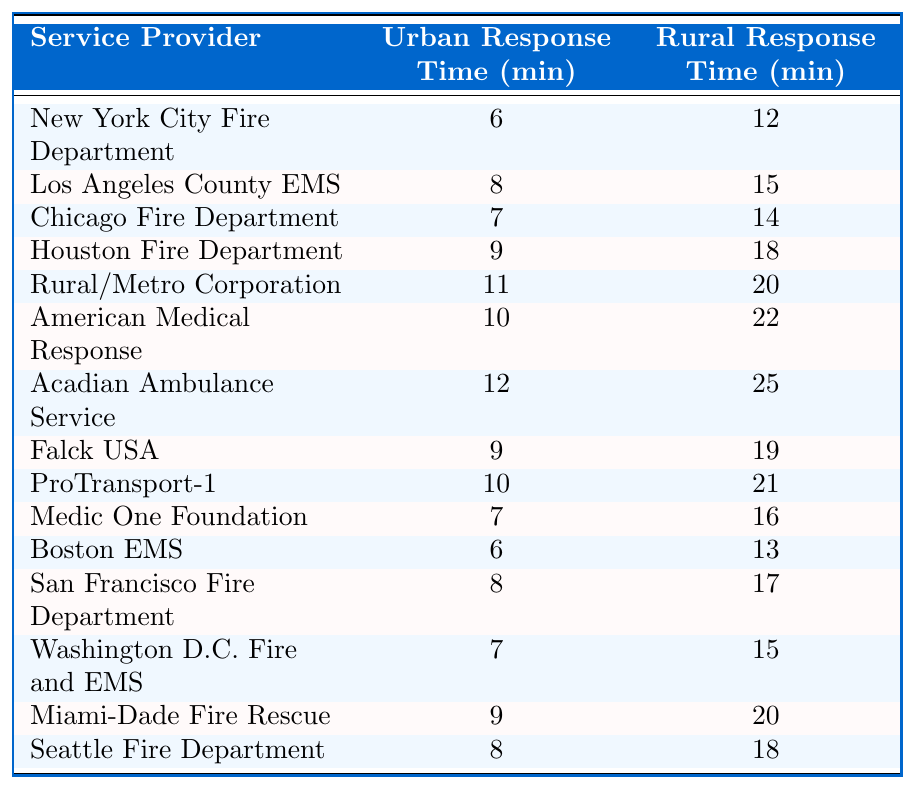What is the urban response time for the Chicago Fire Department? The table indicates that the urban response time for the Chicago Fire Department is listed as 7 minutes.
Answer: 7 minutes What is the rural response time for the Boston EMS? According to the table, the rural response time for the Boston EMS is 13 minutes.
Answer: 13 minutes Which service provider has the fastest urban response time? The New York City Fire Department has the fastest urban response time of 6 minutes, as seen in the table.
Answer: New York City Fire Department What is the average urban response time for all service providers? To find the average, sum the urban response times: 6 + 8 + 7 + 9 + 11 + 10 + 12 + 9 + 10 + 7 + 6 + 8 + 7 + 9 + 8 = 151. There are 15 providers, so the average is 151 / 15 = 10.07, which rounds to approximately 10.1 minutes.
Answer: Approximately 10.1 minutes Which provider has the highest rural response time? The Acadian Ambulance Service has the highest rural response time at 25 minutes, as mentioned in the table.
Answer: Acadian Ambulance Service Is it true that the rural response time is generally higher than urban response time for most service providers? Yes, the data shows that all service providers have a higher rural response time compared to their urban response time.
Answer: Yes What is the difference in response times between urban and rural areas for the American Medical Response? The urban response time is 10 minutes and the rural response time is 22 minutes. The difference is 22 - 10 = 12 minutes.
Answer: 12 minutes How much longer does it take for the Acadian Ambulance Service to respond in rural areas compared to urban areas? The urban response time is 12 minutes while the rural response time is 25 minutes, resulting in a difference of 25 - 12 = 13 minutes.
Answer: 13 minutes What is the median urban response time among all service providers? First, list the urban response times in order: 6, 6, 7, 7, 8, 8, 9, 9, 10, 10, 11, 12. There are 15 data points, so the median is the 8th value, which is 9 minutes.
Answer: 9 minutes Which service provider shows the least discrepancy between urban and rural response times? To find this, compare the differences: NYC FD (6), Los Angeles (7), Chicago (7), etc. The least discrepancy is for the New York City Fire Department, with a difference of 6 minutes.
Answer: New York City Fire Department 